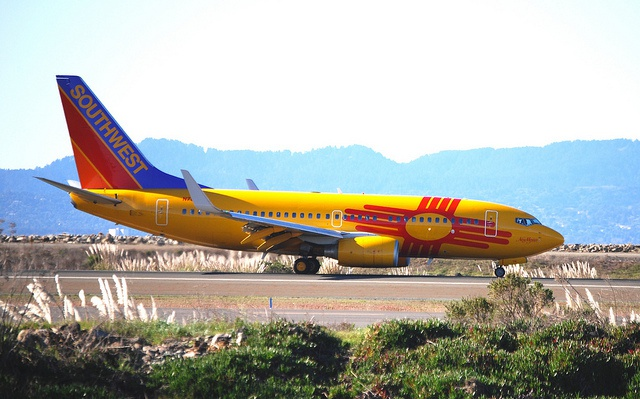Describe the objects in this image and their specific colors. I can see a airplane in lightblue, olive, maroon, and brown tones in this image. 